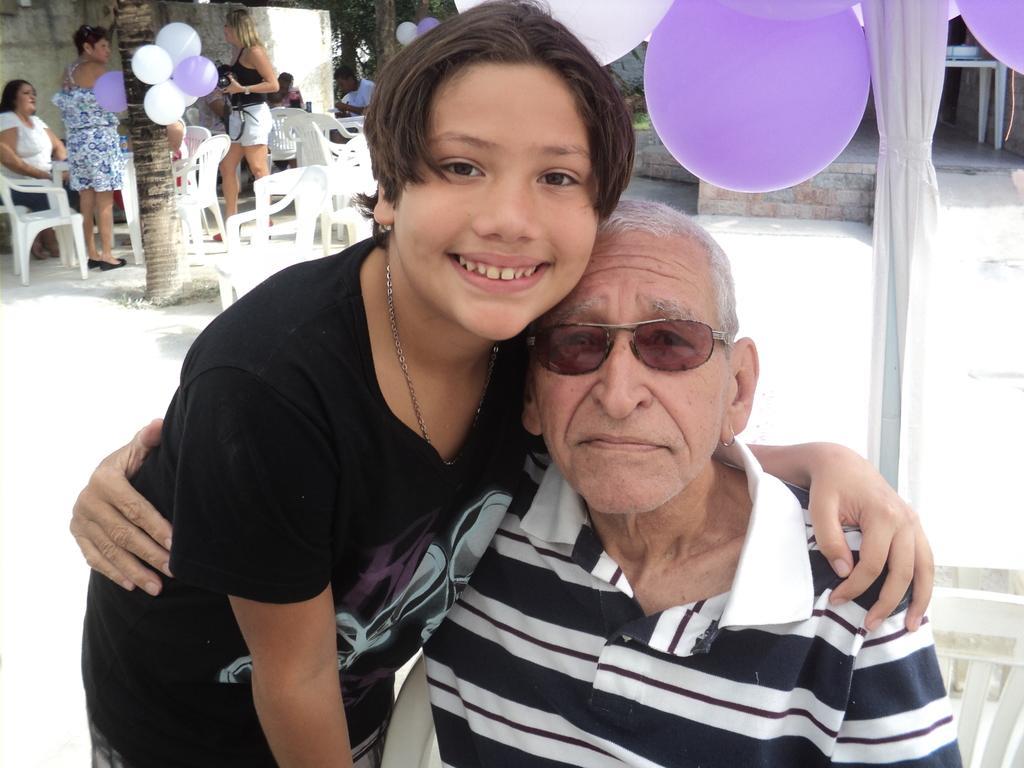Describe this image in one or two sentences. In the image there is a person standing beside an old man and posing for the photo and behind them there are few balloons and on the left side there are few people and around them there are some empty chairs. 